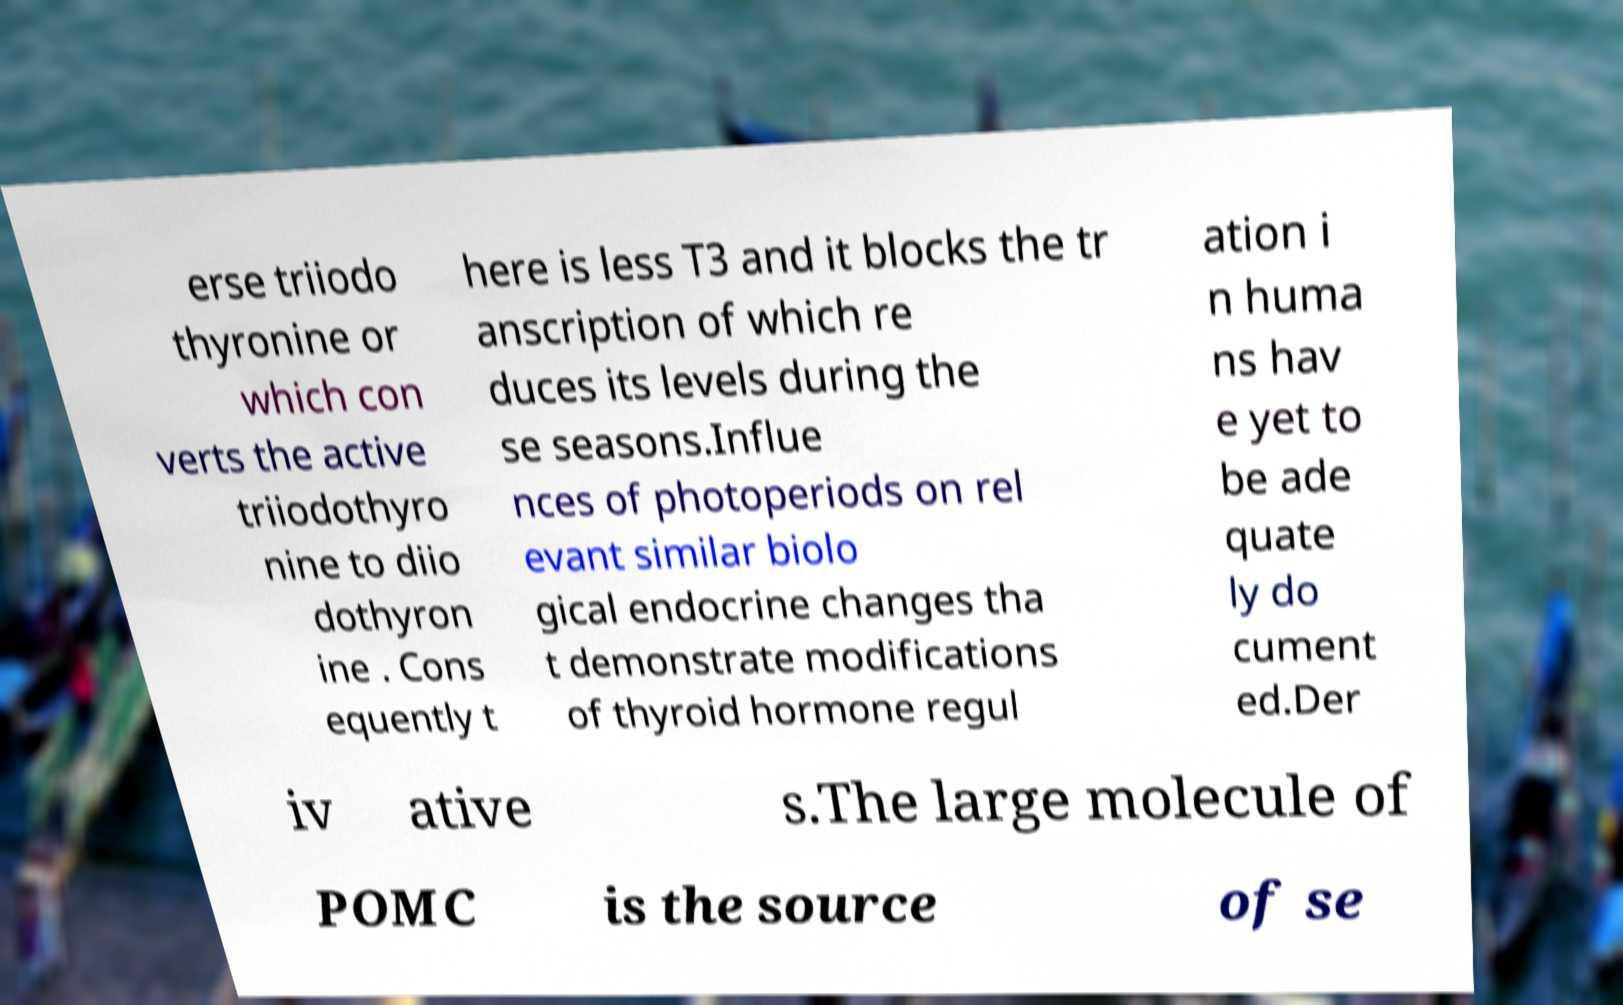For documentation purposes, I need the text within this image transcribed. Could you provide that? erse triiodo thyronine or which con verts the active triiodothyro nine to diio dothyron ine . Cons equently t here is less T3 and it blocks the tr anscription of which re duces its levels during the se seasons.Influe nces of photoperiods on rel evant similar biolo gical endocrine changes tha t demonstrate modifications of thyroid hormone regul ation i n huma ns hav e yet to be ade quate ly do cument ed.Der iv ative s.The large molecule of POMC is the source of se 